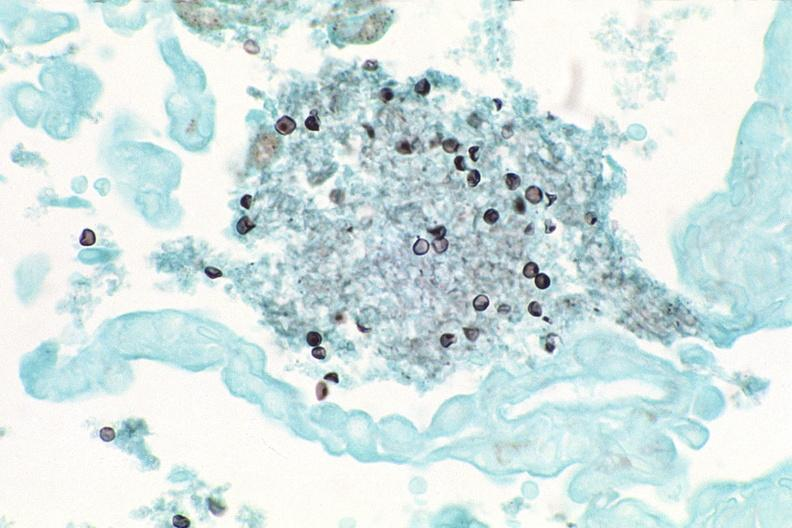what stain?
Answer the question using a single word or phrase. Silver 